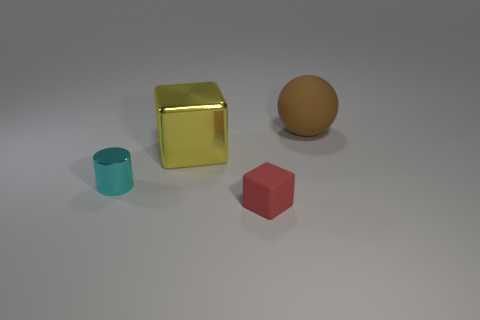What number of shiny objects are either purple cylinders or big yellow blocks?
Ensure brevity in your answer.  1. How many cyan metallic cylinders have the same size as the cyan shiny thing?
Your answer should be compact. 0. What color is the object that is in front of the big metal thing and behind the small red block?
Make the answer very short. Cyan. How many things are either big cyan matte spheres or cylinders?
Provide a succinct answer. 1. How many small things are gray matte cylinders or yellow things?
Provide a succinct answer. 0. Are there any other things that are the same color as the small matte cube?
Give a very brief answer. No. What is the size of the object that is both behind the small metallic object and on the left side of the big brown thing?
Give a very brief answer. Large. There is a metallic object that is in front of the large yellow metallic thing; is its color the same as the block that is on the right side of the yellow thing?
Ensure brevity in your answer.  No. How many other things are there of the same material as the big brown sphere?
Your response must be concise. 1. What shape is the thing that is both on the right side of the cyan cylinder and on the left side of the small red matte block?
Your answer should be compact. Cube. 